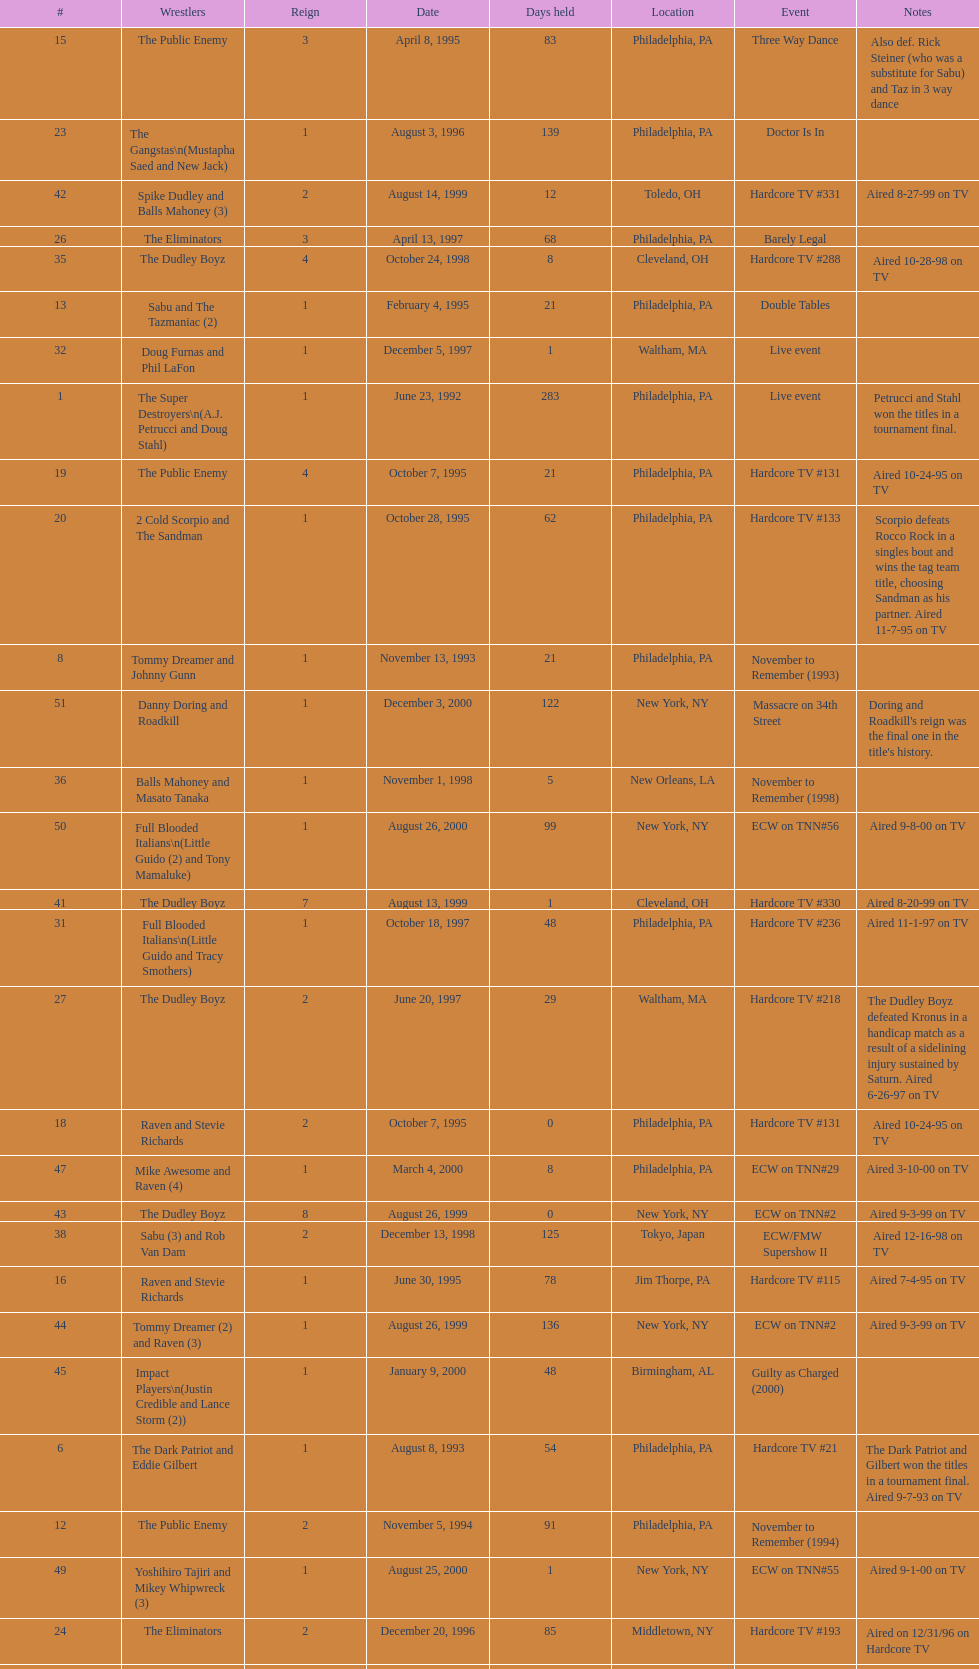What event comes before hardcore tv #14? Hardcore TV #8. Would you mind parsing the complete table? {'header': ['#', 'Wrestlers', 'Reign', 'Date', 'Days held', 'Location', 'Event', 'Notes'], 'rows': [['15', 'The Public Enemy', '3', 'April 8, 1995', '83', 'Philadelphia, PA', 'Three Way Dance', 'Also def. Rick Steiner (who was a substitute for Sabu) and Taz in 3 way dance'], ['23', 'The Gangstas\\n(Mustapha Saed and New Jack)', '1', 'August 3, 1996', '139', 'Philadelphia, PA', 'Doctor Is In', ''], ['42', 'Spike Dudley and Balls Mahoney (3)', '2', 'August 14, 1999', '12', 'Toledo, OH', 'Hardcore TV #331', 'Aired 8-27-99 on TV'], ['26', 'The Eliminators', '3', 'April 13, 1997', '68', 'Philadelphia, PA', 'Barely Legal', ''], ['35', 'The Dudley Boyz', '4', 'October 24, 1998', '8', 'Cleveland, OH', 'Hardcore TV #288', 'Aired 10-28-98 on TV'], ['13', 'Sabu and The Tazmaniac (2)', '1', 'February 4, 1995', '21', 'Philadelphia, PA', 'Double Tables', ''], ['32', 'Doug Furnas and Phil LaFon', '1', 'December 5, 1997', '1', 'Waltham, MA', 'Live event', ''], ['1', 'The Super Destroyers\\n(A.J. Petrucci and Doug Stahl)', '1', 'June 23, 1992', '283', 'Philadelphia, PA', 'Live event', 'Petrucci and Stahl won the titles in a tournament final.'], ['19', 'The Public Enemy', '4', 'October 7, 1995', '21', 'Philadelphia, PA', 'Hardcore TV #131', 'Aired 10-24-95 on TV'], ['20', '2 Cold Scorpio and The Sandman', '1', 'October 28, 1995', '62', 'Philadelphia, PA', 'Hardcore TV #133', 'Scorpio defeats Rocco Rock in a singles bout and wins the tag team title, choosing Sandman as his partner. Aired 11-7-95 on TV'], ['8', 'Tommy Dreamer and Johnny Gunn', '1', 'November 13, 1993', '21', 'Philadelphia, PA', 'November to Remember (1993)', ''], ['51', 'Danny Doring and Roadkill', '1', 'December 3, 2000', '122', 'New York, NY', 'Massacre on 34th Street', "Doring and Roadkill's reign was the final one in the title's history."], ['36', 'Balls Mahoney and Masato Tanaka', '1', 'November 1, 1998', '5', 'New Orleans, LA', 'November to Remember (1998)', ''], ['50', 'Full Blooded Italians\\n(Little Guido (2) and Tony Mamaluke)', '1', 'August 26, 2000', '99', 'New York, NY', 'ECW on TNN#56', 'Aired 9-8-00 on TV'], ['41', 'The Dudley Boyz', '7', 'August 13, 1999', '1', 'Cleveland, OH', 'Hardcore TV #330', 'Aired 8-20-99 on TV'], ['31', 'Full Blooded Italians\\n(Little Guido and Tracy Smothers)', '1', 'October 18, 1997', '48', 'Philadelphia, PA', 'Hardcore TV #236', 'Aired 11-1-97 on TV'], ['27', 'The Dudley Boyz', '2', 'June 20, 1997', '29', 'Waltham, MA', 'Hardcore TV #218', 'The Dudley Boyz defeated Kronus in a handicap match as a result of a sidelining injury sustained by Saturn. Aired 6-26-97 on TV'], ['18', 'Raven and Stevie Richards', '2', 'October 7, 1995', '0', 'Philadelphia, PA', 'Hardcore TV #131', 'Aired 10-24-95 on TV'], ['47', 'Mike Awesome and Raven (4)', '1', 'March 4, 2000', '8', 'Philadelphia, PA', 'ECW on TNN#29', 'Aired 3-10-00 on TV'], ['43', 'The Dudley Boyz', '8', 'August 26, 1999', '0', 'New York, NY', 'ECW on TNN#2', 'Aired 9-3-99 on TV'], ['38', 'Sabu (3) and Rob Van Dam', '2', 'December 13, 1998', '125', 'Tokyo, Japan', 'ECW/FMW Supershow II', 'Aired 12-16-98 on TV'], ['16', 'Raven and Stevie Richards', '1', 'June 30, 1995', '78', 'Jim Thorpe, PA', 'Hardcore TV #115', 'Aired 7-4-95 on TV'], ['44', 'Tommy Dreamer (2) and Raven (3)', '1', 'August 26, 1999', '136', 'New York, NY', 'ECW on TNN#2', 'Aired 9-3-99 on TV'], ['45', 'Impact Players\\n(Justin Credible and Lance Storm (2))', '1', 'January 9, 2000', '48', 'Birmingham, AL', 'Guilty as Charged (2000)', ''], ['6', 'The Dark Patriot and Eddie Gilbert', '1', 'August 8, 1993', '54', 'Philadelphia, PA', 'Hardcore TV #21', 'The Dark Patriot and Gilbert won the titles in a tournament final. Aired 9-7-93 on TV'], ['12', 'The Public Enemy', '2', 'November 5, 1994', '91', 'Philadelphia, PA', 'November to Remember (1994)', ''], ['49', 'Yoshihiro Tajiri and Mikey Whipwreck (3)', '1', 'August 25, 2000', '1', 'New York, NY', 'ECW on TNN#55', 'Aired 9-1-00 on TV'], ['24', 'The Eliminators', '2', 'December 20, 1996', '85', 'Middletown, NY', 'Hardcore TV #193', 'Aired on 12/31/96 on Hardcore TV'], ['40', 'Spike Dudley and Balls Mahoney (2)', '1', 'July 18, 1999', '26', 'Dayton, OH', 'Heat Wave (1999)', ''], ['4', 'The Super Destroyers', '2', 'May 15, 1993', '0', 'Philadelphia, PA', 'Hardcore TV #14', 'Aired 7-6-93 on TV'], ['46', 'Tommy Dreamer (3) and Masato Tanaka (2)', '1', 'February 26, 2000', '7', 'Cincinnati, OH', 'Hardcore TV #358', 'Aired 3-7-00 on TV'], ['37', 'The Dudley Boyz', '5', 'November 6, 1998', '37', 'New York, NY', 'Hardcore TV #290', 'Aired 11-11-98 on TV'], ['—', 'Vacated', '2', 'October 1, 1993', '0', 'Philadelphia, PA', 'Bloodfest: Part 1', 'ECW vacated the championships after The Dark Patriot and Eddie Gilbert left the organization.'], ['14', 'Chris Benoit and Dean Malenko', '1', 'February 25, 1995', '42', 'Philadelphia, PA', 'Return of the Funker', ''], ['21', 'Cactus Jack and Mikey Whipwreck', '2', 'December 29, 1995', '36', 'New York, NY', 'Holiday Hell 1995', "Whipwreck defeated 2 Cold Scorpio in a singles match to win both the tag team titles and the ECW World Television Championship; Cactus Jack came out and declared himself to be Mikey's partner after he won the match."], ['48', 'Impact Players\\n(Justin Credible and Lance Storm (3))', '2', 'March 12, 2000', '31', 'Danbury, CT', 'Living Dangerously', ''], ['22', 'The Eliminators\\n(Kronus and Saturn)', '1', 'February 3, 1996', '182', 'New York, NY', 'Big Apple Blizzard Blast', ''], ['17', 'The Pitbulls\\n(Pitbull #1 and Pitbull #2)', '1', 'September 16, 1995', '21', 'Philadelphia, PA', "Gangsta's Paradise", ''], ['10', 'The Public Enemy\\n(Johnny Grunge and Rocco Rock)', '1', 'March 6, 1994', '174', 'Philadelphia, PA', 'Hardcore TV #46', 'Aired 3-8-94 on TV'], ['29', 'The Dudley Boyz', '3', 'August 17, 1997', '95', 'Fort Lauderdale, FL', 'Hardcore Heaven (1997)', 'The Dudley Boyz won the championship via forfeit as a result of Mustapha Saed leaving the promotion before Hardcore Heaven took place.'], ['33', 'Chris Candido (3) and Lance Storm', '1', 'December 6, 1997', '203', 'Philadelphia, PA', 'Better than Ever', ''], ['5', 'The Suicide Blondes', '2', 'May 15, 1993', '46', 'Philadelphia, PA', 'Hardcore TV #15', 'Aired 7-20-93 on TV'], ['—', 'Vacated', '1', 'July 1993', '39', 'N/A', 'N/A', 'ECW vacated the title after Candido left the promotion for the Smoky Mountain Wrestling organization.'], ['3', 'The Suicide Blondes\\n(Chris Candido, Johnny Hotbody, and Chris Michaels)', '1', 'April 3, 1993', '42', 'Philadelphia, PA', 'Hardcore TV #8', 'All three wrestlers were recognized as champions, and were able to defend the titles in any combination via the Freebird rule. Aired 5-25-93 on TV'], ['25', 'The Dudley Boyz\\n(Buh Buh Ray Dudley and D-Von Dudley)', '1', 'March 15, 1997', '29', 'Philadelphia, PA', 'Hostile City Showdown', 'Aired 3/20/97 on Hardcore TV'], ['39', 'The Dudley Boyz', '6', 'April 17, 1999', '92', 'Buffalo, NY', 'Hardcore TV #313', 'D-Von Dudley defeated Van Dam in a singles match to win the championship for his team. Aired 4-23-99 on TV'], ['11', 'Cactus Jack and Mikey Whipwreck', '1', 'August 27, 1994', '70', 'Philadelphia, PA', 'Hardcore TV #72', 'Whipwreck was a substitute for Terry Funk, who left the company. Aired 9-13-94 on TV'], ['34', 'Sabu (2) and Rob Van Dam', '1', 'June 27, 1998', '119', 'Philadelphia, PA', 'Hardcore TV #271', 'Aired 7-1-98 on TV'], ['7', 'Johnny Hotbody (3) and Tony Stetson (2)', '1', 'October 1, 1993', '43', 'Philadelphia, PA', 'Bloodfest: Part 1', 'Hotbody and Stetson were awarded the titles by ECW.'], ['28', 'The Gangstas', '2', 'July 19, 1997', '29', 'Philadelphia, PA', 'Heat Wave 1997/Hardcore TV #222', 'Aired 7-24-97 on TV'], ['9', 'Kevin Sullivan and The Tazmaniac', '1', 'December 4, 1993', '92', 'Philadelphia, PA', 'Hardcore TV #35', 'Defeat Dreamer and Shane Douglas, who was substituting for an injured Gunn. After the bout, Douglas turned against Dreamer and became a heel. Aired 12-14-93 on TV'], ['2', 'Tony Stetson and Larry Winters', '1', 'April 2, 1993', '1', 'Radnor, PA', 'Hardcore TV #6', 'Aired 5-11-93 on TV'], ['—', 'Vacated', '3', 'April 22, 2000', '125', 'Philadelphia, PA', 'Live event', 'At CyberSlam, Justin Credible threw down the titles to become eligible for the ECW World Heavyweight Championship. Storm later left for World Championship Wrestling. As a result of the circumstances, Credible vacated the championship.'], ['30', 'The Gangstanators\\n(Kronus (4) and New Jack (3))', '1', 'September 20, 1997', '28', 'Philadelphia, PA', 'As Good as it Gets', 'Aired 9-27-97 on TV']]} 